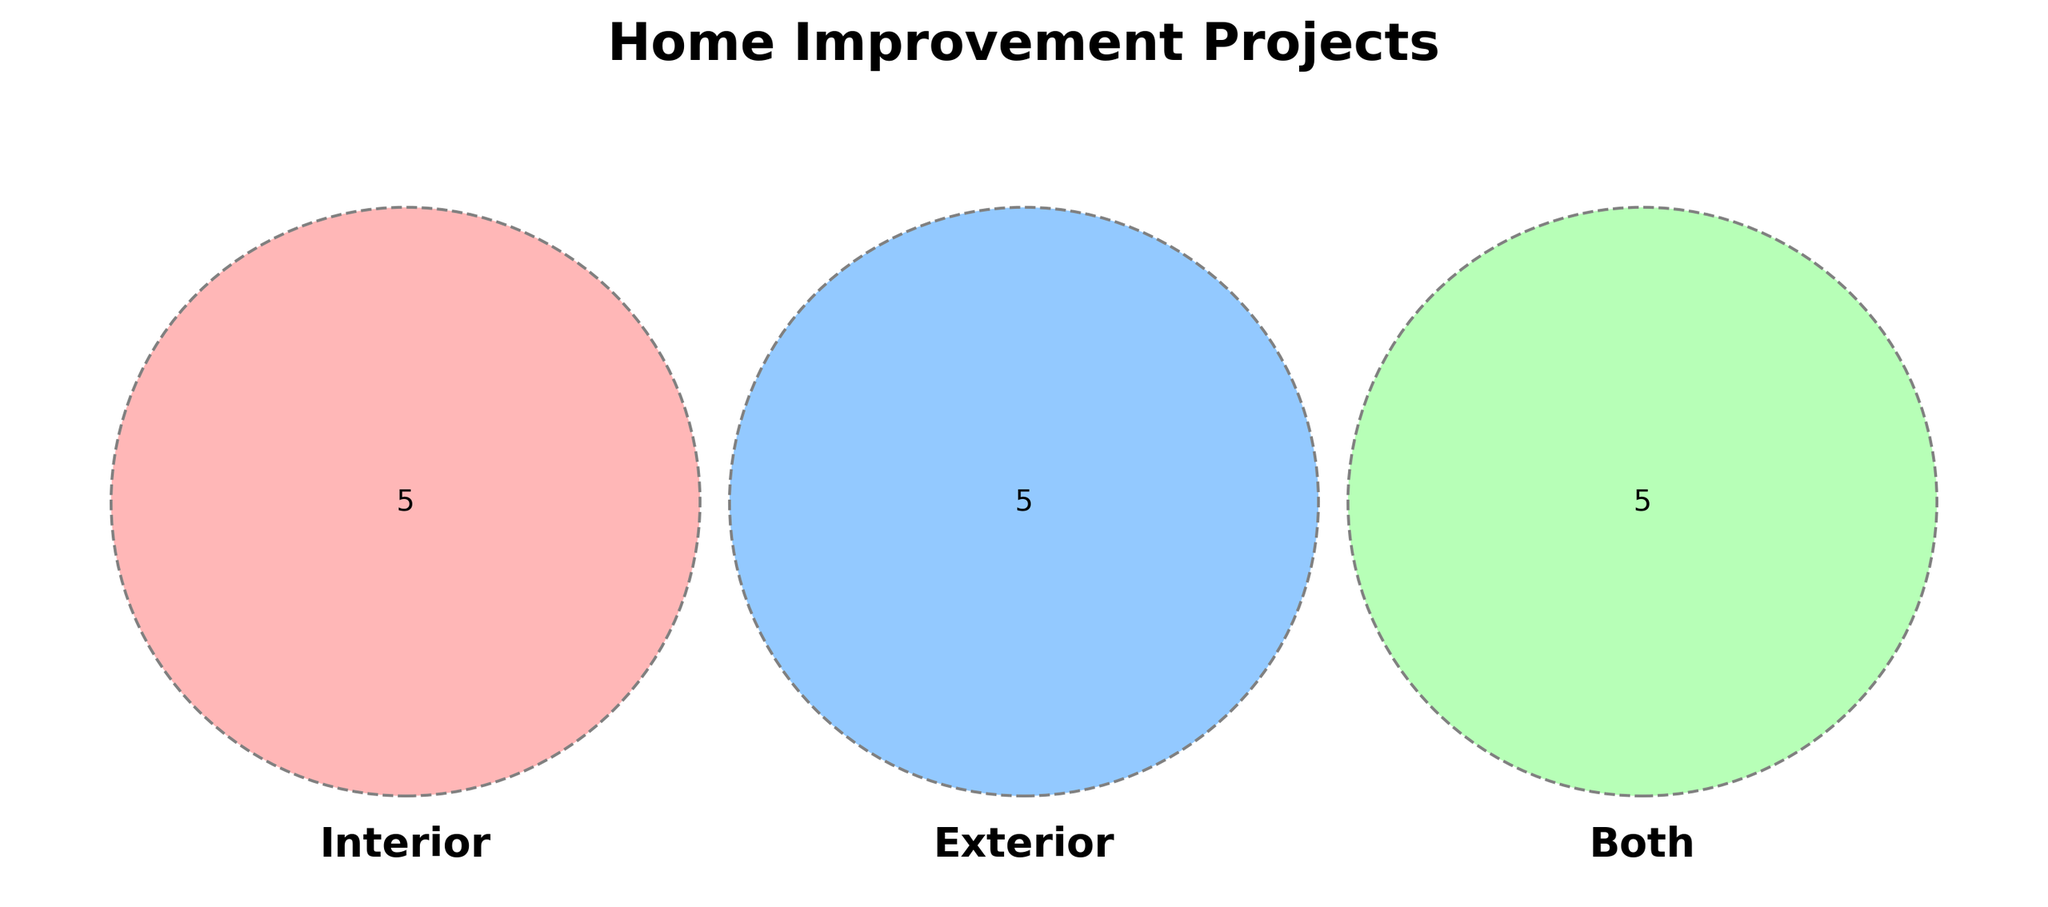What are the main labels in the Venn Diagram? The main labels are "Interior", "Exterior", and "Both", which represent the categories of home improvement projects. These labels help to distinguish the different sets that overlap within the Venn Diagram, showing which projects fall into each category.
Answer: Interior, Exterior, Both What type of projects fall under the "Exterior" category? Projects in the "Exterior" category include "Landscaping", "Deck Building", "Fence Installation", "Well Drilling", and "Gutter Repair". These projects are outside the house and enhance the exterior aspects.
Answer: Landscaping, Deck Building, Fence Installation, Well Drilling, Gutter Repair Which projects appear in the "Both" section? Projects in the "Both" section include "Kitchen Remodel", "Bathroom Renovation", "Insulation", "Window Replacement", and "Roof Repair". These projects affect both the interior and exterior aspects of the house.
Answer: Kitchen Remodel, Bathroom Renovation, Insulation, Window Replacement, Roof Repair How many projects are exclusively classified as "Interior"? There are five projects exclusively classified as "Interior": "Painting", "Flooring", "Wallpapering", "Lighting Fixtures", and "Closet Organization". Each of these projects is specifically aimed at the inside of the house.
Answer: 5 Which section has the most overlapping projects? The "Both" section has the most overlapping projects with a total of five projects. These projects are of a type that affects both interior and exterior parts of a house.
Answer: Both Is "Well Drilling" considered an interior, exterior, or both type of project? "Well Drilling" is considered an exterior type of project. It is included in the list of projects specifically for the exterior category.
Answer: Exterior What is the total number of unique projects represented in the diagram? To find the total number of unique projects, we count all the projects listed across "Interior", "Exterior", and "Both", ensuring not to count any project twice. There are 20 unique projects in total when considering overlaps.
Answer: 20 Are there any shared projects between "Interior" and "Exterior" that are not classified under "Both"? Since "shared projects" by definition fall under "Both" in this diagram, there are no projects shared between "Interior" and "Exterior" that are not classified under "Both".
Answer: No What's the ratio of exclusively "Interior" projects to exclusively "Exterior" projects? Exclusive "Interior" projects are five: "Painting", "Flooring", "Wallpapering", "Lighting Fixtures", "Closet Organization". Exclusive "Exterior" projects are also five: "Landscaping", "Deck Building", "Fence Installation", "Well Drilling", "Gutter Repair". So, the ratio is 5:5 or 1:1.
Answer: 1:1 Which category does "Insulation" fall into based on the diagram? "Insulation" falls into the "Both" category. It is listed under the "Both" projects, indicating it affects both the interior and exterior of the house.
Answer: Both 